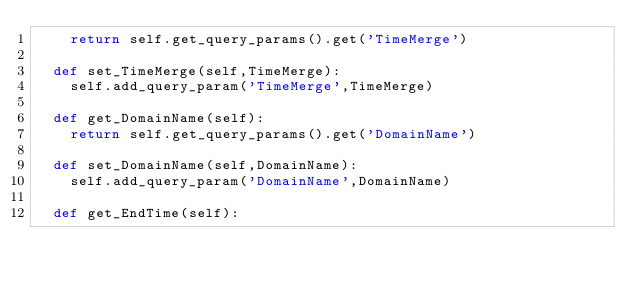<code> <loc_0><loc_0><loc_500><loc_500><_Python_>		return self.get_query_params().get('TimeMerge')

	def set_TimeMerge(self,TimeMerge):
		self.add_query_param('TimeMerge',TimeMerge)

	def get_DomainName(self):
		return self.get_query_params().get('DomainName')

	def set_DomainName(self,DomainName):
		self.add_query_param('DomainName',DomainName)

	def get_EndTime(self):</code> 